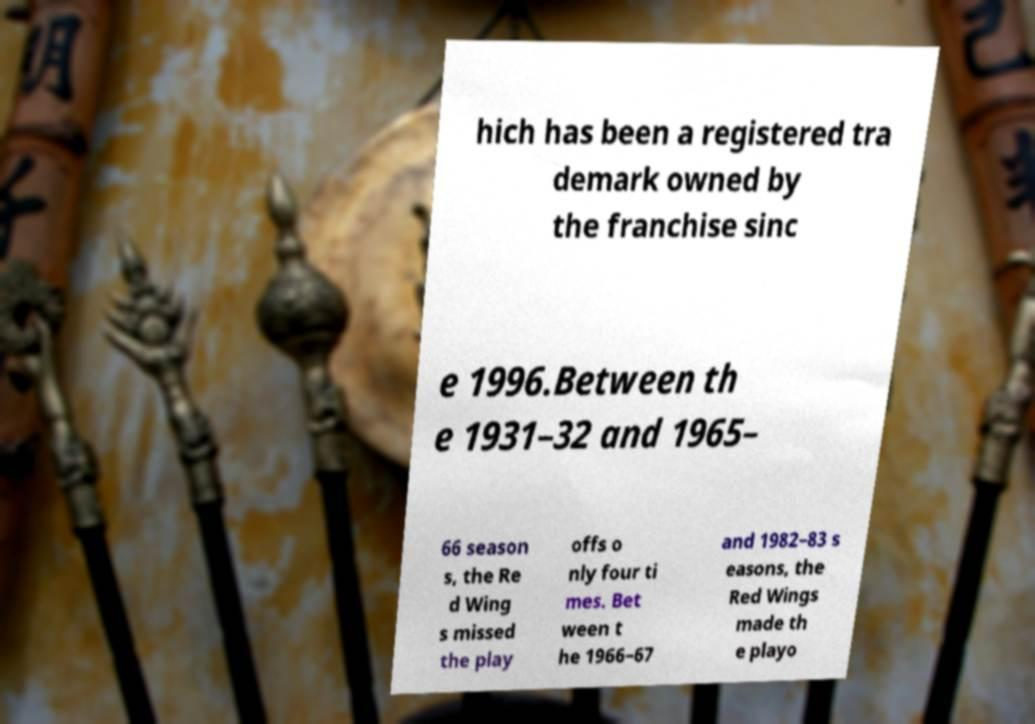Can you read and provide the text displayed in the image?This photo seems to have some interesting text. Can you extract and type it out for me? hich has been a registered tra demark owned by the franchise sinc e 1996.Between th e 1931–32 and 1965– 66 season s, the Re d Wing s missed the play offs o nly four ti mes. Bet ween t he 1966–67 and 1982–83 s easons, the Red Wings made th e playo 